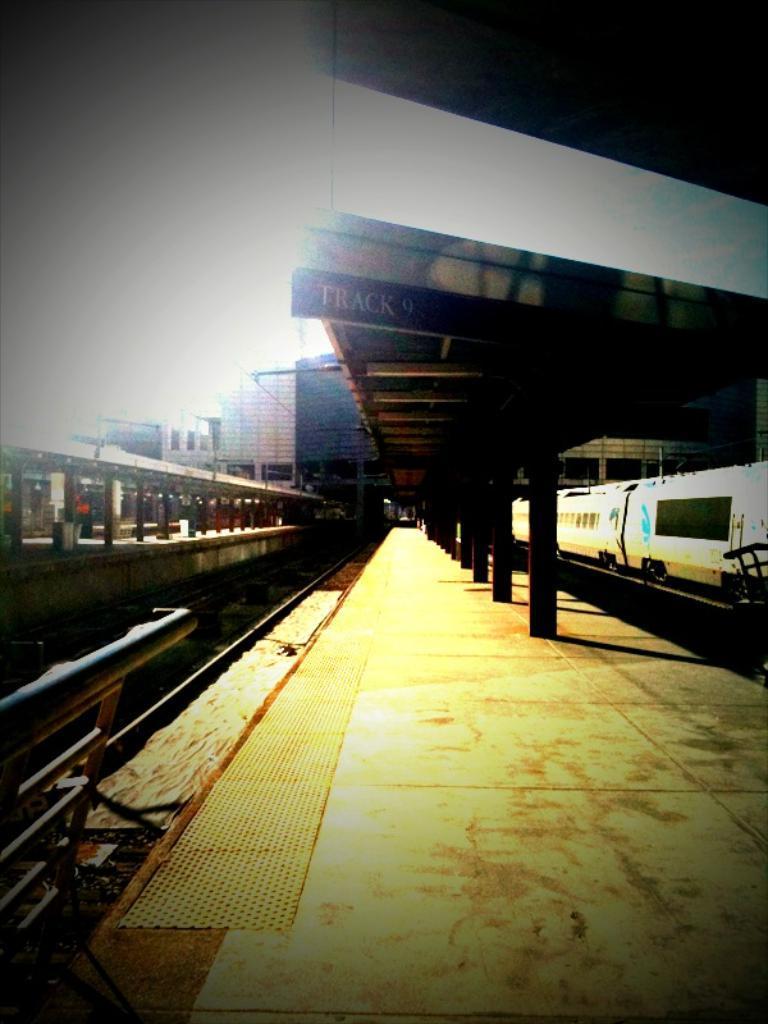Could you give a brief overview of what you see in this image? In this image we can see there is a railway platform and a shed above it, on the right side of the image there is a train and on the left side of the image there is a railway track and a shed. 